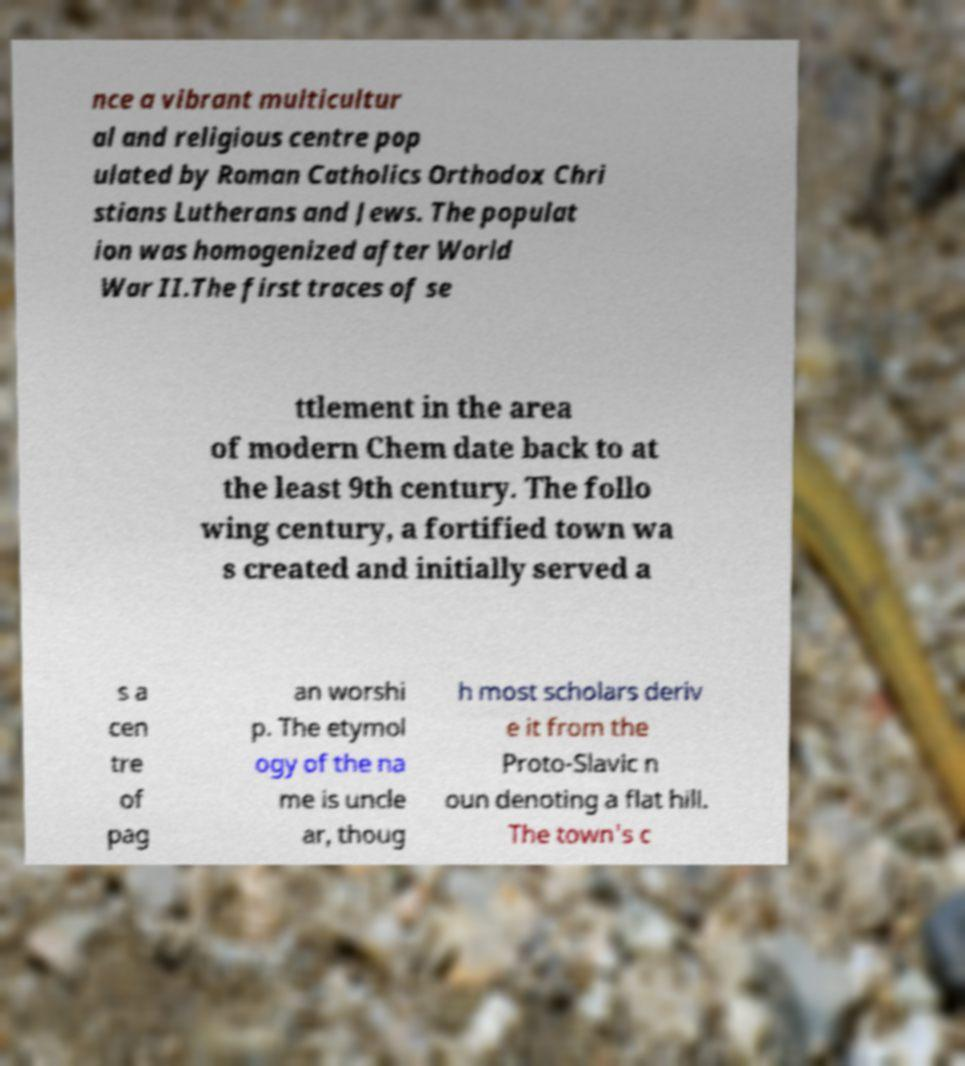Please read and relay the text visible in this image. What does it say? nce a vibrant multicultur al and religious centre pop ulated by Roman Catholics Orthodox Chri stians Lutherans and Jews. The populat ion was homogenized after World War II.The first traces of se ttlement in the area of modern Chem date back to at the least 9th century. The follo wing century, a fortified town wa s created and initially served a s a cen tre of pag an worshi p. The etymol ogy of the na me is uncle ar, thoug h most scholars deriv e it from the Proto-Slavic n oun denoting a flat hill. The town's c 